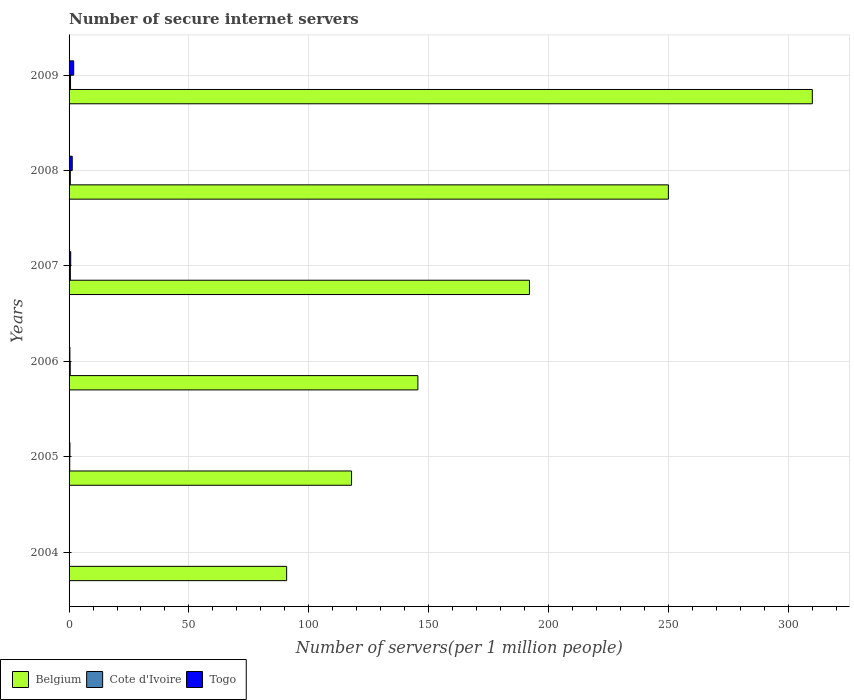How many different coloured bars are there?
Keep it short and to the point. 3. How many groups of bars are there?
Your response must be concise. 6. How many bars are there on the 4th tick from the top?
Your answer should be compact. 3. What is the label of the 5th group of bars from the top?
Provide a succinct answer. 2005. In how many cases, is the number of bars for a given year not equal to the number of legend labels?
Your response must be concise. 0. What is the number of secure internet servers in Togo in 2005?
Your answer should be very brief. 0.36. Across all years, what is the maximum number of secure internet servers in Togo?
Ensure brevity in your answer.  1.93. Across all years, what is the minimum number of secure internet servers in Cote d'Ivoire?
Keep it short and to the point. 0.17. In which year was the number of secure internet servers in Belgium maximum?
Your answer should be compact. 2009. What is the total number of secure internet servers in Togo in the graph?
Your response must be concise. 4.82. What is the difference between the number of secure internet servers in Cote d'Ivoire in 2005 and that in 2006?
Offer a very short reply. -0.21. What is the difference between the number of secure internet servers in Belgium in 2004 and the number of secure internet servers in Cote d'Ivoire in 2007?
Keep it short and to the point. 90.25. What is the average number of secure internet servers in Belgium per year?
Make the answer very short. 184.4. In the year 2004, what is the difference between the number of secure internet servers in Togo and number of secure internet servers in Belgium?
Offer a terse response. -90.59. In how many years, is the number of secure internet servers in Cote d'Ivoire greater than 150 ?
Offer a terse response. 0. What is the ratio of the number of secure internet servers in Belgium in 2004 to that in 2005?
Ensure brevity in your answer.  0.77. Is the difference between the number of secure internet servers in Togo in 2005 and 2007 greater than the difference between the number of secure internet servers in Belgium in 2005 and 2007?
Ensure brevity in your answer.  Yes. What is the difference between the highest and the second highest number of secure internet servers in Togo?
Your response must be concise. 0.61. What is the difference between the highest and the lowest number of secure internet servers in Belgium?
Keep it short and to the point. 219.32. Is the sum of the number of secure internet servers in Togo in 2006 and 2008 greater than the maximum number of secure internet servers in Cote d'Ivoire across all years?
Your answer should be compact. Yes. What does the 3rd bar from the top in 2007 represents?
Keep it short and to the point. Belgium. What does the 3rd bar from the bottom in 2005 represents?
Keep it short and to the point. Togo. Is it the case that in every year, the sum of the number of secure internet servers in Belgium and number of secure internet servers in Togo is greater than the number of secure internet servers in Cote d'Ivoire?
Your answer should be compact. Yes. How many bars are there?
Offer a terse response. 18. Are all the bars in the graph horizontal?
Make the answer very short. Yes. Are the values on the major ticks of X-axis written in scientific E-notation?
Keep it short and to the point. No. Does the graph contain any zero values?
Ensure brevity in your answer.  No. Where does the legend appear in the graph?
Your answer should be compact. Bottom left. How many legend labels are there?
Ensure brevity in your answer.  3. What is the title of the graph?
Offer a terse response. Number of secure internet servers. Does "Yemen, Rep." appear as one of the legend labels in the graph?
Your response must be concise. No. What is the label or title of the X-axis?
Your answer should be very brief. Number of servers(per 1 million people). What is the Number of servers(per 1 million people) in Belgium in 2004?
Give a very brief answer. 90.78. What is the Number of servers(per 1 million people) in Cote d'Ivoire in 2004?
Provide a short and direct response. 0.17. What is the Number of servers(per 1 million people) of Togo in 2004?
Make the answer very short. 0.18. What is the Number of servers(per 1 million people) in Belgium in 2005?
Your response must be concise. 117.86. What is the Number of servers(per 1 million people) of Cote d'Ivoire in 2005?
Your answer should be compact. 0.28. What is the Number of servers(per 1 million people) of Togo in 2005?
Make the answer very short. 0.36. What is the Number of servers(per 1 million people) of Belgium in 2006?
Your response must be concise. 145.53. What is the Number of servers(per 1 million people) of Cote d'Ivoire in 2006?
Your answer should be compact. 0.49. What is the Number of servers(per 1 million people) in Togo in 2006?
Offer a terse response. 0.35. What is the Number of servers(per 1 million people) in Belgium in 2007?
Your answer should be compact. 192.08. What is the Number of servers(per 1 million people) in Cote d'Ivoire in 2007?
Provide a succinct answer. 0.53. What is the Number of servers(per 1 million people) of Togo in 2007?
Offer a terse response. 0.68. What is the Number of servers(per 1 million people) of Belgium in 2008?
Provide a short and direct response. 250.05. What is the Number of servers(per 1 million people) of Cote d'Ivoire in 2008?
Give a very brief answer. 0.52. What is the Number of servers(per 1 million people) of Togo in 2008?
Make the answer very short. 1.32. What is the Number of servers(per 1 million people) of Belgium in 2009?
Provide a short and direct response. 310.1. What is the Number of servers(per 1 million people) of Cote d'Ivoire in 2009?
Your response must be concise. 0.61. What is the Number of servers(per 1 million people) of Togo in 2009?
Your answer should be very brief. 1.93. Across all years, what is the maximum Number of servers(per 1 million people) of Belgium?
Offer a very short reply. 310.1. Across all years, what is the maximum Number of servers(per 1 million people) of Cote d'Ivoire?
Ensure brevity in your answer.  0.61. Across all years, what is the maximum Number of servers(per 1 million people) in Togo?
Make the answer very short. 1.93. Across all years, what is the minimum Number of servers(per 1 million people) in Belgium?
Your response must be concise. 90.78. Across all years, what is the minimum Number of servers(per 1 million people) in Cote d'Ivoire?
Your answer should be compact. 0.17. Across all years, what is the minimum Number of servers(per 1 million people) in Togo?
Give a very brief answer. 0.18. What is the total Number of servers(per 1 million people) of Belgium in the graph?
Your answer should be very brief. 1106.39. What is the total Number of servers(per 1 million people) in Cote d'Ivoire in the graph?
Keep it short and to the point. 2.59. What is the total Number of servers(per 1 million people) of Togo in the graph?
Make the answer very short. 4.82. What is the difference between the Number of servers(per 1 million people) of Belgium in 2004 and that in 2005?
Provide a succinct answer. -27.08. What is the difference between the Number of servers(per 1 million people) in Cote d'Ivoire in 2004 and that in 2005?
Ensure brevity in your answer.  -0.11. What is the difference between the Number of servers(per 1 million people) of Togo in 2004 and that in 2005?
Keep it short and to the point. -0.17. What is the difference between the Number of servers(per 1 million people) of Belgium in 2004 and that in 2006?
Give a very brief answer. -54.75. What is the difference between the Number of servers(per 1 million people) of Cote d'Ivoire in 2004 and that in 2006?
Keep it short and to the point. -0.32. What is the difference between the Number of servers(per 1 million people) of Togo in 2004 and that in 2006?
Keep it short and to the point. -0.16. What is the difference between the Number of servers(per 1 million people) in Belgium in 2004 and that in 2007?
Offer a very short reply. -101.3. What is the difference between the Number of servers(per 1 million people) of Cote d'Ivoire in 2004 and that in 2007?
Ensure brevity in your answer.  -0.36. What is the difference between the Number of servers(per 1 million people) in Togo in 2004 and that in 2007?
Ensure brevity in your answer.  -0.49. What is the difference between the Number of servers(per 1 million people) of Belgium in 2004 and that in 2008?
Offer a very short reply. -159.27. What is the difference between the Number of servers(per 1 million people) of Cote d'Ivoire in 2004 and that in 2008?
Give a very brief answer. -0.35. What is the difference between the Number of servers(per 1 million people) in Togo in 2004 and that in 2008?
Offer a very short reply. -1.14. What is the difference between the Number of servers(per 1 million people) of Belgium in 2004 and that in 2009?
Provide a succinct answer. -219.32. What is the difference between the Number of servers(per 1 million people) in Cote d'Ivoire in 2004 and that in 2009?
Offer a terse response. -0.44. What is the difference between the Number of servers(per 1 million people) in Togo in 2004 and that in 2009?
Your answer should be very brief. -1.75. What is the difference between the Number of servers(per 1 million people) in Belgium in 2005 and that in 2006?
Provide a short and direct response. -27.67. What is the difference between the Number of servers(per 1 million people) of Cote d'Ivoire in 2005 and that in 2006?
Make the answer very short. -0.21. What is the difference between the Number of servers(per 1 million people) of Togo in 2005 and that in 2006?
Provide a short and direct response. 0.01. What is the difference between the Number of servers(per 1 million people) of Belgium in 2005 and that in 2007?
Your answer should be compact. -74.22. What is the difference between the Number of servers(per 1 million people) in Cote d'Ivoire in 2005 and that in 2007?
Make the answer very short. -0.25. What is the difference between the Number of servers(per 1 million people) in Togo in 2005 and that in 2007?
Your response must be concise. -0.32. What is the difference between the Number of servers(per 1 million people) in Belgium in 2005 and that in 2008?
Ensure brevity in your answer.  -132.19. What is the difference between the Number of servers(per 1 million people) in Cote d'Ivoire in 2005 and that in 2008?
Make the answer very short. -0.24. What is the difference between the Number of servers(per 1 million people) in Togo in 2005 and that in 2008?
Provide a succinct answer. -0.96. What is the difference between the Number of servers(per 1 million people) of Belgium in 2005 and that in 2009?
Provide a short and direct response. -192.24. What is the difference between the Number of servers(per 1 million people) in Cote d'Ivoire in 2005 and that in 2009?
Provide a succinct answer. -0.33. What is the difference between the Number of servers(per 1 million people) of Togo in 2005 and that in 2009?
Keep it short and to the point. -1.57. What is the difference between the Number of servers(per 1 million people) in Belgium in 2006 and that in 2007?
Provide a succinct answer. -46.56. What is the difference between the Number of servers(per 1 million people) of Cote d'Ivoire in 2006 and that in 2007?
Provide a short and direct response. -0.04. What is the difference between the Number of servers(per 1 million people) of Togo in 2006 and that in 2007?
Make the answer very short. -0.33. What is the difference between the Number of servers(per 1 million people) of Belgium in 2006 and that in 2008?
Offer a very short reply. -104.52. What is the difference between the Number of servers(per 1 million people) of Cote d'Ivoire in 2006 and that in 2008?
Offer a terse response. -0.03. What is the difference between the Number of servers(per 1 million people) in Togo in 2006 and that in 2008?
Offer a very short reply. -0.97. What is the difference between the Number of servers(per 1 million people) in Belgium in 2006 and that in 2009?
Give a very brief answer. -164.57. What is the difference between the Number of servers(per 1 million people) of Cote d'Ivoire in 2006 and that in 2009?
Provide a short and direct response. -0.12. What is the difference between the Number of servers(per 1 million people) in Togo in 2006 and that in 2009?
Provide a succinct answer. -1.58. What is the difference between the Number of servers(per 1 million people) of Belgium in 2007 and that in 2008?
Your answer should be very brief. -57.97. What is the difference between the Number of servers(per 1 million people) in Cote d'Ivoire in 2007 and that in 2008?
Offer a terse response. 0.01. What is the difference between the Number of servers(per 1 million people) in Togo in 2007 and that in 2008?
Provide a succinct answer. -0.64. What is the difference between the Number of servers(per 1 million people) of Belgium in 2007 and that in 2009?
Ensure brevity in your answer.  -118.02. What is the difference between the Number of servers(per 1 million people) of Cote d'Ivoire in 2007 and that in 2009?
Provide a succinct answer. -0.08. What is the difference between the Number of servers(per 1 million people) of Togo in 2007 and that in 2009?
Ensure brevity in your answer.  -1.25. What is the difference between the Number of servers(per 1 million people) of Belgium in 2008 and that in 2009?
Offer a very short reply. -60.05. What is the difference between the Number of servers(per 1 million people) in Cote d'Ivoire in 2008 and that in 2009?
Give a very brief answer. -0.09. What is the difference between the Number of servers(per 1 million people) of Togo in 2008 and that in 2009?
Ensure brevity in your answer.  -0.61. What is the difference between the Number of servers(per 1 million people) of Belgium in 2004 and the Number of servers(per 1 million people) of Cote d'Ivoire in 2005?
Provide a succinct answer. 90.5. What is the difference between the Number of servers(per 1 million people) in Belgium in 2004 and the Number of servers(per 1 million people) in Togo in 2005?
Provide a short and direct response. 90.42. What is the difference between the Number of servers(per 1 million people) of Cote d'Ivoire in 2004 and the Number of servers(per 1 million people) of Togo in 2005?
Your answer should be compact. -0.19. What is the difference between the Number of servers(per 1 million people) of Belgium in 2004 and the Number of servers(per 1 million people) of Cote d'Ivoire in 2006?
Offer a very short reply. 90.29. What is the difference between the Number of servers(per 1 million people) of Belgium in 2004 and the Number of servers(per 1 million people) of Togo in 2006?
Ensure brevity in your answer.  90.43. What is the difference between the Number of servers(per 1 million people) in Cote d'Ivoire in 2004 and the Number of servers(per 1 million people) in Togo in 2006?
Your answer should be very brief. -0.18. What is the difference between the Number of servers(per 1 million people) in Belgium in 2004 and the Number of servers(per 1 million people) in Cote d'Ivoire in 2007?
Your answer should be very brief. 90.25. What is the difference between the Number of servers(per 1 million people) in Belgium in 2004 and the Number of servers(per 1 million people) in Togo in 2007?
Provide a succinct answer. 90.1. What is the difference between the Number of servers(per 1 million people) in Cote d'Ivoire in 2004 and the Number of servers(per 1 million people) in Togo in 2007?
Give a very brief answer. -0.51. What is the difference between the Number of servers(per 1 million people) in Belgium in 2004 and the Number of servers(per 1 million people) in Cote d'Ivoire in 2008?
Your answer should be compact. 90.26. What is the difference between the Number of servers(per 1 million people) of Belgium in 2004 and the Number of servers(per 1 million people) of Togo in 2008?
Provide a short and direct response. 89.46. What is the difference between the Number of servers(per 1 million people) in Cote d'Ivoire in 2004 and the Number of servers(per 1 million people) in Togo in 2008?
Provide a short and direct response. -1.15. What is the difference between the Number of servers(per 1 million people) in Belgium in 2004 and the Number of servers(per 1 million people) in Cote d'Ivoire in 2009?
Offer a very short reply. 90.17. What is the difference between the Number of servers(per 1 million people) in Belgium in 2004 and the Number of servers(per 1 million people) in Togo in 2009?
Provide a short and direct response. 88.85. What is the difference between the Number of servers(per 1 million people) in Cote d'Ivoire in 2004 and the Number of servers(per 1 million people) in Togo in 2009?
Offer a terse response. -1.76. What is the difference between the Number of servers(per 1 million people) in Belgium in 2005 and the Number of servers(per 1 million people) in Cote d'Ivoire in 2006?
Make the answer very short. 117.37. What is the difference between the Number of servers(per 1 million people) of Belgium in 2005 and the Number of servers(per 1 million people) of Togo in 2006?
Provide a short and direct response. 117.51. What is the difference between the Number of servers(per 1 million people) in Cote d'Ivoire in 2005 and the Number of servers(per 1 million people) in Togo in 2006?
Provide a succinct answer. -0.07. What is the difference between the Number of servers(per 1 million people) of Belgium in 2005 and the Number of servers(per 1 million people) of Cote d'Ivoire in 2007?
Ensure brevity in your answer.  117.33. What is the difference between the Number of servers(per 1 million people) of Belgium in 2005 and the Number of servers(per 1 million people) of Togo in 2007?
Give a very brief answer. 117.18. What is the difference between the Number of servers(per 1 million people) in Cote d'Ivoire in 2005 and the Number of servers(per 1 million people) in Togo in 2007?
Your answer should be very brief. -0.4. What is the difference between the Number of servers(per 1 million people) in Belgium in 2005 and the Number of servers(per 1 million people) in Cote d'Ivoire in 2008?
Offer a terse response. 117.34. What is the difference between the Number of servers(per 1 million people) in Belgium in 2005 and the Number of servers(per 1 million people) in Togo in 2008?
Your answer should be compact. 116.54. What is the difference between the Number of servers(per 1 million people) of Cote d'Ivoire in 2005 and the Number of servers(per 1 million people) of Togo in 2008?
Your answer should be very brief. -1.05. What is the difference between the Number of servers(per 1 million people) of Belgium in 2005 and the Number of servers(per 1 million people) of Cote d'Ivoire in 2009?
Make the answer very short. 117.25. What is the difference between the Number of servers(per 1 million people) in Belgium in 2005 and the Number of servers(per 1 million people) in Togo in 2009?
Provide a short and direct response. 115.93. What is the difference between the Number of servers(per 1 million people) of Cote d'Ivoire in 2005 and the Number of servers(per 1 million people) of Togo in 2009?
Make the answer very short. -1.65. What is the difference between the Number of servers(per 1 million people) in Belgium in 2006 and the Number of servers(per 1 million people) in Cote d'Ivoire in 2007?
Ensure brevity in your answer.  145. What is the difference between the Number of servers(per 1 million people) in Belgium in 2006 and the Number of servers(per 1 million people) in Togo in 2007?
Make the answer very short. 144.85. What is the difference between the Number of servers(per 1 million people) in Cote d'Ivoire in 2006 and the Number of servers(per 1 million people) in Togo in 2007?
Your answer should be very brief. -0.19. What is the difference between the Number of servers(per 1 million people) in Belgium in 2006 and the Number of servers(per 1 million people) in Cote d'Ivoire in 2008?
Provide a succinct answer. 145.01. What is the difference between the Number of servers(per 1 million people) in Belgium in 2006 and the Number of servers(per 1 million people) in Togo in 2008?
Your answer should be compact. 144.2. What is the difference between the Number of servers(per 1 million people) in Cote d'Ivoire in 2006 and the Number of servers(per 1 million people) in Togo in 2008?
Provide a short and direct response. -0.83. What is the difference between the Number of servers(per 1 million people) of Belgium in 2006 and the Number of servers(per 1 million people) of Cote d'Ivoire in 2009?
Offer a terse response. 144.92. What is the difference between the Number of servers(per 1 million people) of Belgium in 2006 and the Number of servers(per 1 million people) of Togo in 2009?
Keep it short and to the point. 143.6. What is the difference between the Number of servers(per 1 million people) of Cote d'Ivoire in 2006 and the Number of servers(per 1 million people) of Togo in 2009?
Ensure brevity in your answer.  -1.44. What is the difference between the Number of servers(per 1 million people) in Belgium in 2007 and the Number of servers(per 1 million people) in Cote d'Ivoire in 2008?
Provide a short and direct response. 191.56. What is the difference between the Number of servers(per 1 million people) in Belgium in 2007 and the Number of servers(per 1 million people) in Togo in 2008?
Your answer should be very brief. 190.76. What is the difference between the Number of servers(per 1 million people) of Cote d'Ivoire in 2007 and the Number of servers(per 1 million people) of Togo in 2008?
Keep it short and to the point. -0.79. What is the difference between the Number of servers(per 1 million people) of Belgium in 2007 and the Number of servers(per 1 million people) of Cote d'Ivoire in 2009?
Make the answer very short. 191.47. What is the difference between the Number of servers(per 1 million people) of Belgium in 2007 and the Number of servers(per 1 million people) of Togo in 2009?
Ensure brevity in your answer.  190.15. What is the difference between the Number of servers(per 1 million people) in Cote d'Ivoire in 2007 and the Number of servers(per 1 million people) in Togo in 2009?
Provide a succinct answer. -1.4. What is the difference between the Number of servers(per 1 million people) in Belgium in 2008 and the Number of servers(per 1 million people) in Cote d'Ivoire in 2009?
Your answer should be compact. 249.44. What is the difference between the Number of servers(per 1 million people) in Belgium in 2008 and the Number of servers(per 1 million people) in Togo in 2009?
Your answer should be very brief. 248.12. What is the difference between the Number of servers(per 1 million people) in Cote d'Ivoire in 2008 and the Number of servers(per 1 million people) in Togo in 2009?
Provide a succinct answer. -1.41. What is the average Number of servers(per 1 million people) of Belgium per year?
Give a very brief answer. 184.4. What is the average Number of servers(per 1 million people) of Cote d'Ivoire per year?
Offer a very short reply. 0.43. What is the average Number of servers(per 1 million people) in Togo per year?
Offer a terse response. 0.8. In the year 2004, what is the difference between the Number of servers(per 1 million people) of Belgium and Number of servers(per 1 million people) of Cote d'Ivoire?
Offer a very short reply. 90.61. In the year 2004, what is the difference between the Number of servers(per 1 million people) of Belgium and Number of servers(per 1 million people) of Togo?
Give a very brief answer. 90.59. In the year 2004, what is the difference between the Number of servers(per 1 million people) of Cote d'Ivoire and Number of servers(per 1 million people) of Togo?
Make the answer very short. -0.02. In the year 2005, what is the difference between the Number of servers(per 1 million people) in Belgium and Number of servers(per 1 million people) in Cote d'Ivoire?
Your response must be concise. 117.58. In the year 2005, what is the difference between the Number of servers(per 1 million people) of Belgium and Number of servers(per 1 million people) of Togo?
Give a very brief answer. 117.5. In the year 2005, what is the difference between the Number of servers(per 1 million people) in Cote d'Ivoire and Number of servers(per 1 million people) in Togo?
Offer a terse response. -0.08. In the year 2006, what is the difference between the Number of servers(per 1 million people) in Belgium and Number of servers(per 1 million people) in Cote d'Ivoire?
Give a very brief answer. 145.04. In the year 2006, what is the difference between the Number of servers(per 1 million people) of Belgium and Number of servers(per 1 million people) of Togo?
Keep it short and to the point. 145.18. In the year 2006, what is the difference between the Number of servers(per 1 million people) in Cote d'Ivoire and Number of servers(per 1 million people) in Togo?
Offer a terse response. 0.14. In the year 2007, what is the difference between the Number of servers(per 1 million people) in Belgium and Number of servers(per 1 million people) in Cote d'Ivoire?
Provide a succinct answer. 191.55. In the year 2007, what is the difference between the Number of servers(per 1 million people) of Belgium and Number of servers(per 1 million people) of Togo?
Give a very brief answer. 191.4. In the year 2007, what is the difference between the Number of servers(per 1 million people) in Cote d'Ivoire and Number of servers(per 1 million people) in Togo?
Your answer should be compact. -0.15. In the year 2008, what is the difference between the Number of servers(per 1 million people) in Belgium and Number of servers(per 1 million people) in Cote d'Ivoire?
Offer a terse response. 249.53. In the year 2008, what is the difference between the Number of servers(per 1 million people) of Belgium and Number of servers(per 1 million people) of Togo?
Give a very brief answer. 248.73. In the year 2008, what is the difference between the Number of servers(per 1 million people) of Cote d'Ivoire and Number of servers(per 1 million people) of Togo?
Keep it short and to the point. -0.8. In the year 2009, what is the difference between the Number of servers(per 1 million people) of Belgium and Number of servers(per 1 million people) of Cote d'Ivoire?
Provide a short and direct response. 309.49. In the year 2009, what is the difference between the Number of servers(per 1 million people) in Belgium and Number of servers(per 1 million people) in Togo?
Provide a succinct answer. 308.17. In the year 2009, what is the difference between the Number of servers(per 1 million people) in Cote d'Ivoire and Number of servers(per 1 million people) in Togo?
Provide a succinct answer. -1.32. What is the ratio of the Number of servers(per 1 million people) in Belgium in 2004 to that in 2005?
Your answer should be compact. 0.77. What is the ratio of the Number of servers(per 1 million people) of Cote d'Ivoire in 2004 to that in 2005?
Ensure brevity in your answer.  0.61. What is the ratio of the Number of servers(per 1 million people) in Togo in 2004 to that in 2005?
Your answer should be very brief. 0.51. What is the ratio of the Number of servers(per 1 million people) in Belgium in 2004 to that in 2006?
Your response must be concise. 0.62. What is the ratio of the Number of servers(per 1 million people) of Cote d'Ivoire in 2004 to that in 2006?
Your answer should be very brief. 0.35. What is the ratio of the Number of servers(per 1 million people) of Togo in 2004 to that in 2006?
Provide a succinct answer. 0.53. What is the ratio of the Number of servers(per 1 million people) in Belgium in 2004 to that in 2007?
Keep it short and to the point. 0.47. What is the ratio of the Number of servers(per 1 million people) of Cote d'Ivoire in 2004 to that in 2007?
Offer a terse response. 0.32. What is the ratio of the Number of servers(per 1 million people) of Togo in 2004 to that in 2007?
Give a very brief answer. 0.27. What is the ratio of the Number of servers(per 1 million people) of Belgium in 2004 to that in 2008?
Keep it short and to the point. 0.36. What is the ratio of the Number of servers(per 1 million people) in Cote d'Ivoire in 2004 to that in 2008?
Provide a succinct answer. 0.32. What is the ratio of the Number of servers(per 1 million people) of Togo in 2004 to that in 2008?
Your answer should be very brief. 0.14. What is the ratio of the Number of servers(per 1 million people) in Belgium in 2004 to that in 2009?
Provide a short and direct response. 0.29. What is the ratio of the Number of servers(per 1 million people) of Cote d'Ivoire in 2004 to that in 2009?
Provide a short and direct response. 0.28. What is the ratio of the Number of servers(per 1 million people) of Togo in 2004 to that in 2009?
Your response must be concise. 0.1. What is the ratio of the Number of servers(per 1 million people) in Belgium in 2005 to that in 2006?
Your answer should be compact. 0.81. What is the ratio of the Number of servers(per 1 million people) in Cote d'Ivoire in 2005 to that in 2006?
Offer a terse response. 0.57. What is the ratio of the Number of servers(per 1 million people) of Togo in 2005 to that in 2006?
Keep it short and to the point. 1.03. What is the ratio of the Number of servers(per 1 million people) of Belgium in 2005 to that in 2007?
Ensure brevity in your answer.  0.61. What is the ratio of the Number of servers(per 1 million people) in Cote d'Ivoire in 2005 to that in 2007?
Your answer should be very brief. 0.52. What is the ratio of the Number of servers(per 1 million people) in Togo in 2005 to that in 2007?
Offer a terse response. 0.53. What is the ratio of the Number of servers(per 1 million people) of Belgium in 2005 to that in 2008?
Your response must be concise. 0.47. What is the ratio of the Number of servers(per 1 million people) of Cote d'Ivoire in 2005 to that in 2008?
Offer a terse response. 0.53. What is the ratio of the Number of servers(per 1 million people) of Togo in 2005 to that in 2008?
Keep it short and to the point. 0.27. What is the ratio of the Number of servers(per 1 million people) in Belgium in 2005 to that in 2009?
Your answer should be very brief. 0.38. What is the ratio of the Number of servers(per 1 million people) in Cote d'Ivoire in 2005 to that in 2009?
Give a very brief answer. 0.45. What is the ratio of the Number of servers(per 1 million people) of Togo in 2005 to that in 2009?
Ensure brevity in your answer.  0.19. What is the ratio of the Number of servers(per 1 million people) of Belgium in 2006 to that in 2007?
Your answer should be compact. 0.76. What is the ratio of the Number of servers(per 1 million people) in Cote d'Ivoire in 2006 to that in 2007?
Your answer should be compact. 0.92. What is the ratio of the Number of servers(per 1 million people) of Togo in 2006 to that in 2007?
Your answer should be compact. 0.51. What is the ratio of the Number of servers(per 1 million people) of Belgium in 2006 to that in 2008?
Your response must be concise. 0.58. What is the ratio of the Number of servers(per 1 million people) of Cote d'Ivoire in 2006 to that in 2008?
Make the answer very short. 0.94. What is the ratio of the Number of servers(per 1 million people) of Togo in 2006 to that in 2008?
Provide a succinct answer. 0.26. What is the ratio of the Number of servers(per 1 million people) of Belgium in 2006 to that in 2009?
Your response must be concise. 0.47. What is the ratio of the Number of servers(per 1 million people) in Cote d'Ivoire in 2006 to that in 2009?
Your answer should be very brief. 0.8. What is the ratio of the Number of servers(per 1 million people) of Togo in 2006 to that in 2009?
Provide a short and direct response. 0.18. What is the ratio of the Number of servers(per 1 million people) in Belgium in 2007 to that in 2008?
Your answer should be very brief. 0.77. What is the ratio of the Number of servers(per 1 million people) in Cote d'Ivoire in 2007 to that in 2008?
Your response must be concise. 1.02. What is the ratio of the Number of servers(per 1 million people) of Togo in 2007 to that in 2008?
Ensure brevity in your answer.  0.51. What is the ratio of the Number of servers(per 1 million people) of Belgium in 2007 to that in 2009?
Give a very brief answer. 0.62. What is the ratio of the Number of servers(per 1 million people) of Cote d'Ivoire in 2007 to that in 2009?
Provide a succinct answer. 0.87. What is the ratio of the Number of servers(per 1 million people) of Togo in 2007 to that in 2009?
Your response must be concise. 0.35. What is the ratio of the Number of servers(per 1 million people) in Belgium in 2008 to that in 2009?
Offer a terse response. 0.81. What is the ratio of the Number of servers(per 1 million people) in Cote d'Ivoire in 2008 to that in 2009?
Offer a terse response. 0.85. What is the ratio of the Number of servers(per 1 million people) in Togo in 2008 to that in 2009?
Offer a terse response. 0.69. What is the difference between the highest and the second highest Number of servers(per 1 million people) of Belgium?
Ensure brevity in your answer.  60.05. What is the difference between the highest and the second highest Number of servers(per 1 million people) in Cote d'Ivoire?
Your response must be concise. 0.08. What is the difference between the highest and the second highest Number of servers(per 1 million people) in Togo?
Your answer should be compact. 0.61. What is the difference between the highest and the lowest Number of servers(per 1 million people) of Belgium?
Offer a terse response. 219.32. What is the difference between the highest and the lowest Number of servers(per 1 million people) in Cote d'Ivoire?
Your response must be concise. 0.44. What is the difference between the highest and the lowest Number of servers(per 1 million people) of Togo?
Your answer should be very brief. 1.75. 